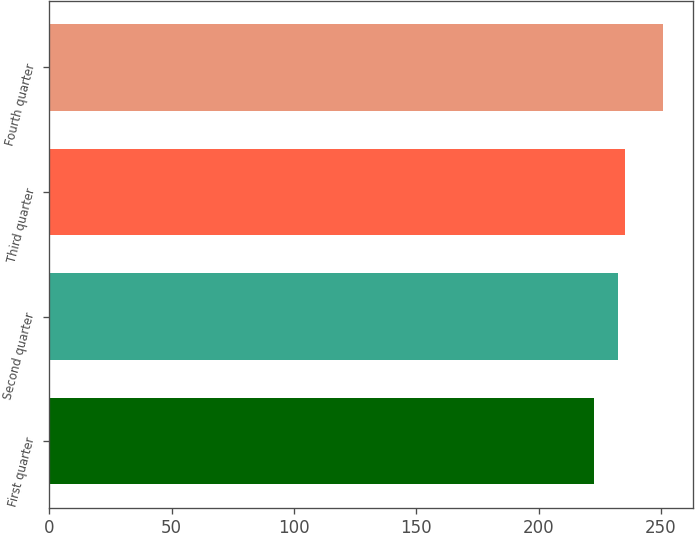Convert chart to OTSL. <chart><loc_0><loc_0><loc_500><loc_500><bar_chart><fcel>First quarter<fcel>Second quarter<fcel>Third quarter<fcel>Fourth quarter<nl><fcel>222.75<fcel>232.41<fcel>235.2<fcel>250.7<nl></chart> 